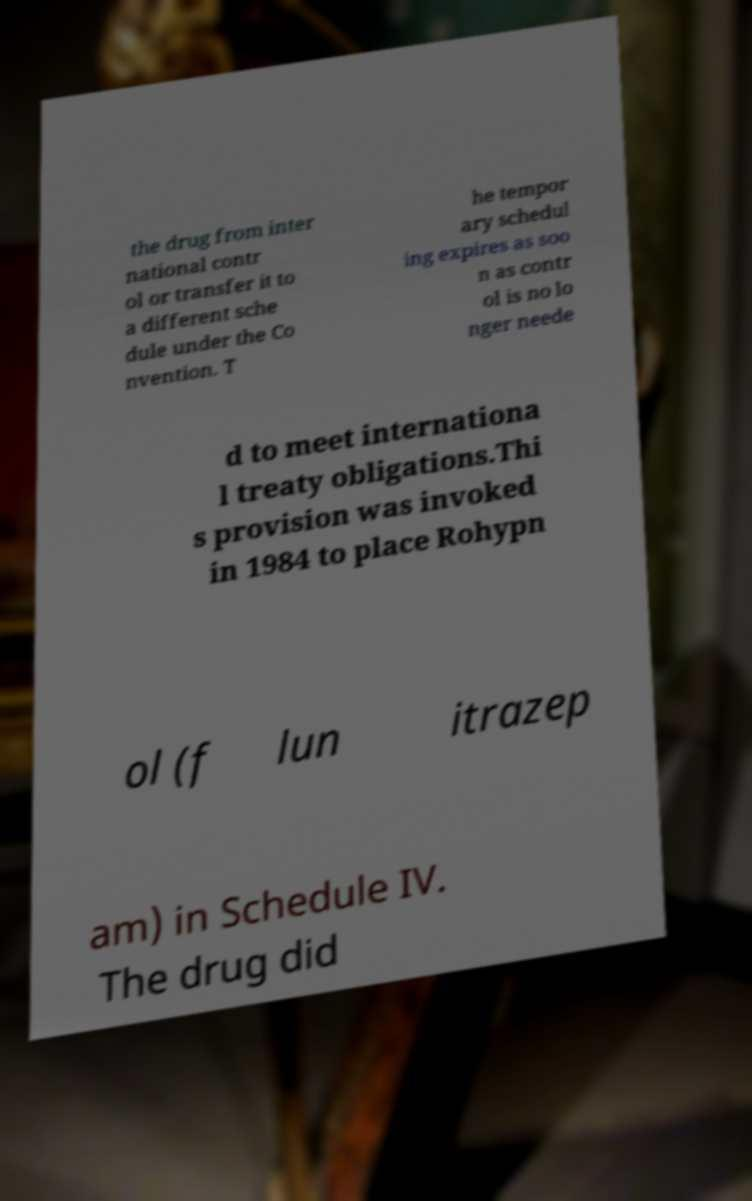For documentation purposes, I need the text within this image transcribed. Could you provide that? the drug from inter national contr ol or transfer it to a different sche dule under the Co nvention. T he tempor ary schedul ing expires as soo n as contr ol is no lo nger neede d to meet internationa l treaty obligations.Thi s provision was invoked in 1984 to place Rohypn ol (f lun itrazep am) in Schedule IV. The drug did 